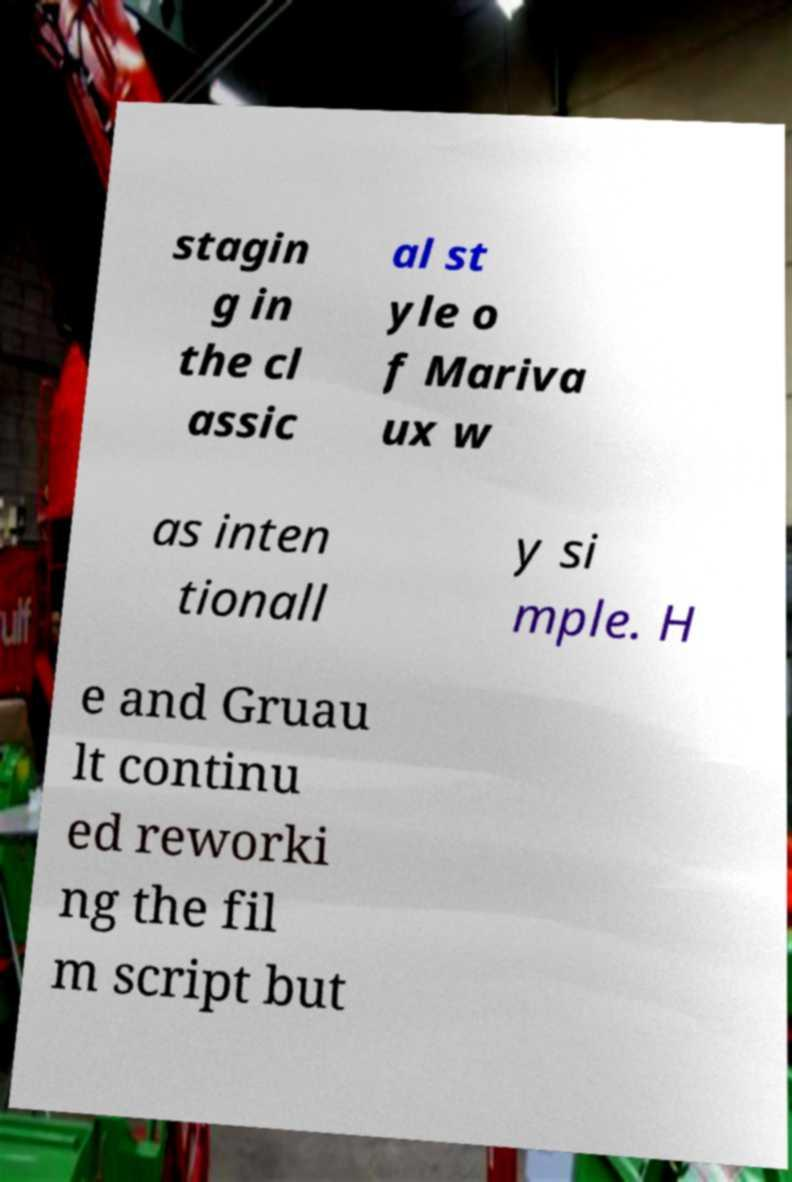Can you read and provide the text displayed in the image?This photo seems to have some interesting text. Can you extract and type it out for me? stagin g in the cl assic al st yle o f Mariva ux w as inten tionall y si mple. H e and Gruau lt continu ed reworki ng the fil m script but 